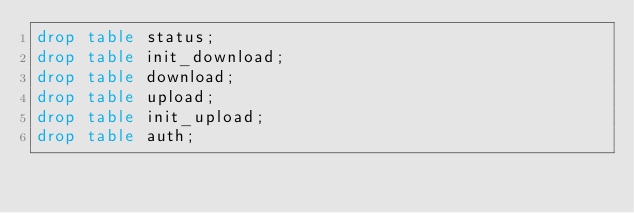<code> <loc_0><loc_0><loc_500><loc_500><_SQL_>drop table status;
drop table init_download;
drop table download;
drop table upload;
drop table init_upload;
drop table auth;
</code> 